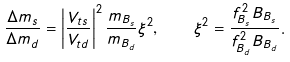Convert formula to latex. <formula><loc_0><loc_0><loc_500><loc_500>\frac { \Delta m _ { s } } { \Delta m _ { d } } = \left | \frac { V _ { t s } } { V _ { t d } } \right | ^ { 2 } \frac { m _ { B _ { s } } } { m _ { B _ { d } } } \xi ^ { 2 } , \quad \xi ^ { 2 } = \frac { f _ { B _ { s } } ^ { 2 } B _ { B _ { s } } } { f _ { B _ { d } } ^ { 2 } B _ { B _ { d } } } .</formula> 